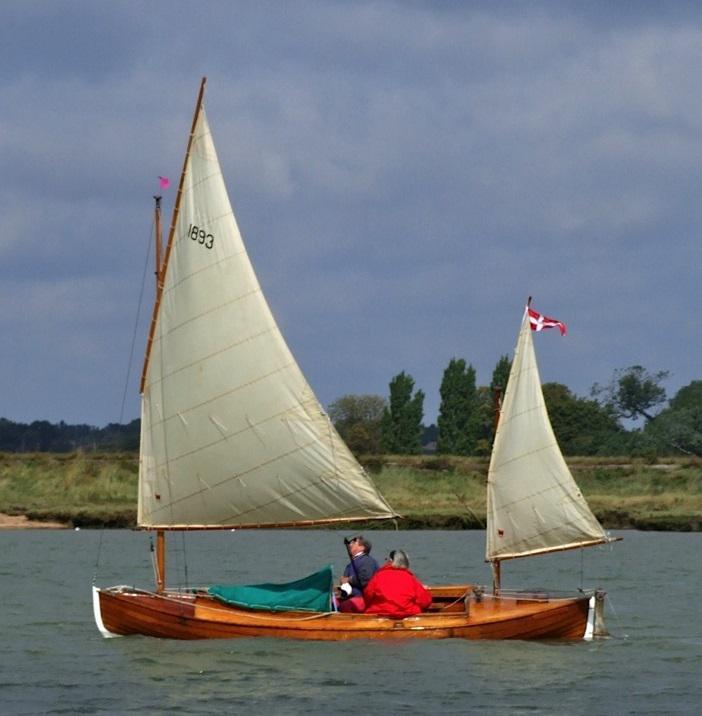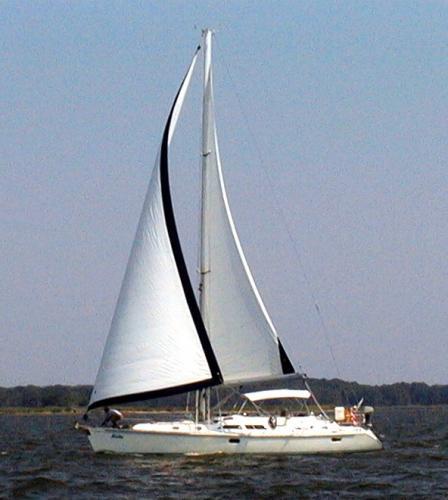The first image is the image on the left, the second image is the image on the right. Given the left and right images, does the statement "There is a person in a red coat in one of the images" hold true? Answer yes or no. Yes. The first image is the image on the left, the second image is the image on the right. For the images displayed, is the sentence "Exactly two people are visible and seated in a boat with a wood interior." factually correct? Answer yes or no. Yes. 